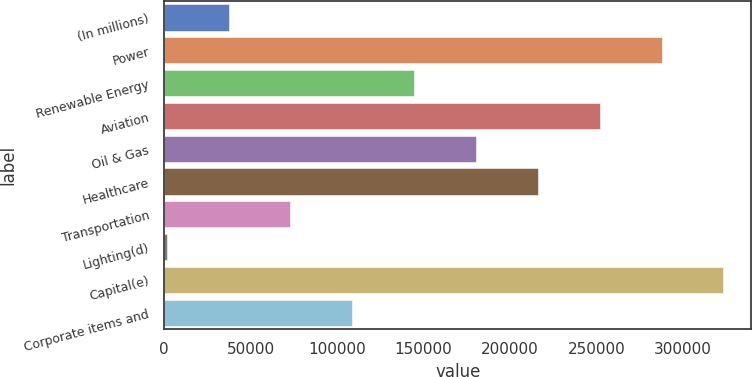Convert chart. <chart><loc_0><loc_0><loc_500><loc_500><bar_chart><fcel>(In millions)<fcel>Power<fcel>Renewable Energy<fcel>Aviation<fcel>Oil & Gas<fcel>Healthcare<fcel>Transportation<fcel>Lighting(d)<fcel>Capital(e)<fcel>Corporate items and<nl><fcel>37325.2<fcel>287612<fcel>144591<fcel>251856<fcel>180346<fcel>216101<fcel>73080.4<fcel>1570<fcel>323367<fcel>108836<nl></chart> 